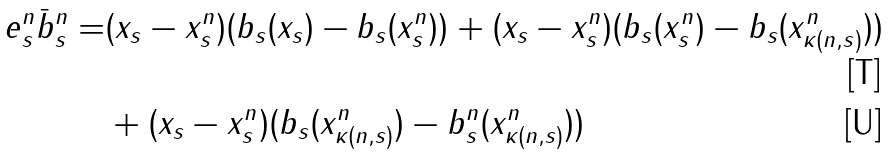Convert formula to latex. <formula><loc_0><loc_0><loc_500><loc_500>e ^ { n } _ { s } \bar { b } ^ { n } _ { s } = & ( x _ { s } - x _ { s } ^ { n } ) ( b _ { s } ( x _ { s } ) - b _ { s } ( x ^ { n } _ { s } ) ) + ( x _ { s } - x ^ { n } _ { s } ) ( b _ { s } ( x ^ { n } _ { s } ) - b _ { s } ( x ^ { n } _ { \kappa ( n , s ) } ) ) \\ & + ( x _ { s } - x ^ { n } _ { s } ) ( b _ { s } ( x ^ { n } _ { \kappa ( n , s ) } ) - b _ { s } ^ { n } ( x ^ { n } _ { \kappa ( n , s ) } ) )</formula> 